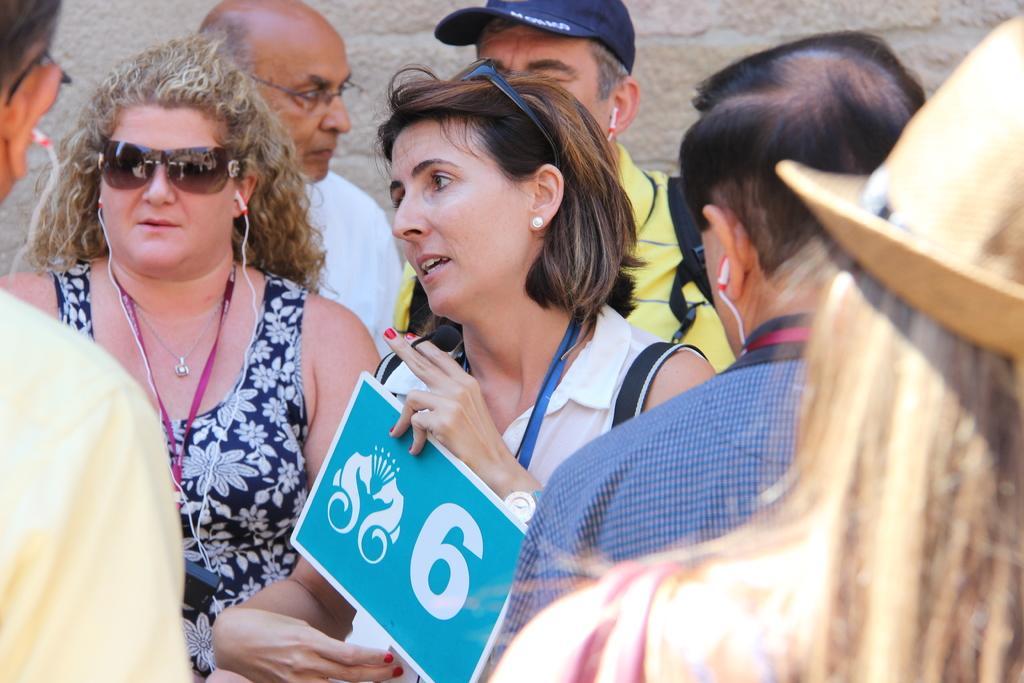Can you describe this image briefly? In this image I can see number of people. I can also see few of them are using earphones and I can see one of them is wearing a cap. Here I can see she is holding a board and on it I can see something is written. I can also see she is wearing shades. 